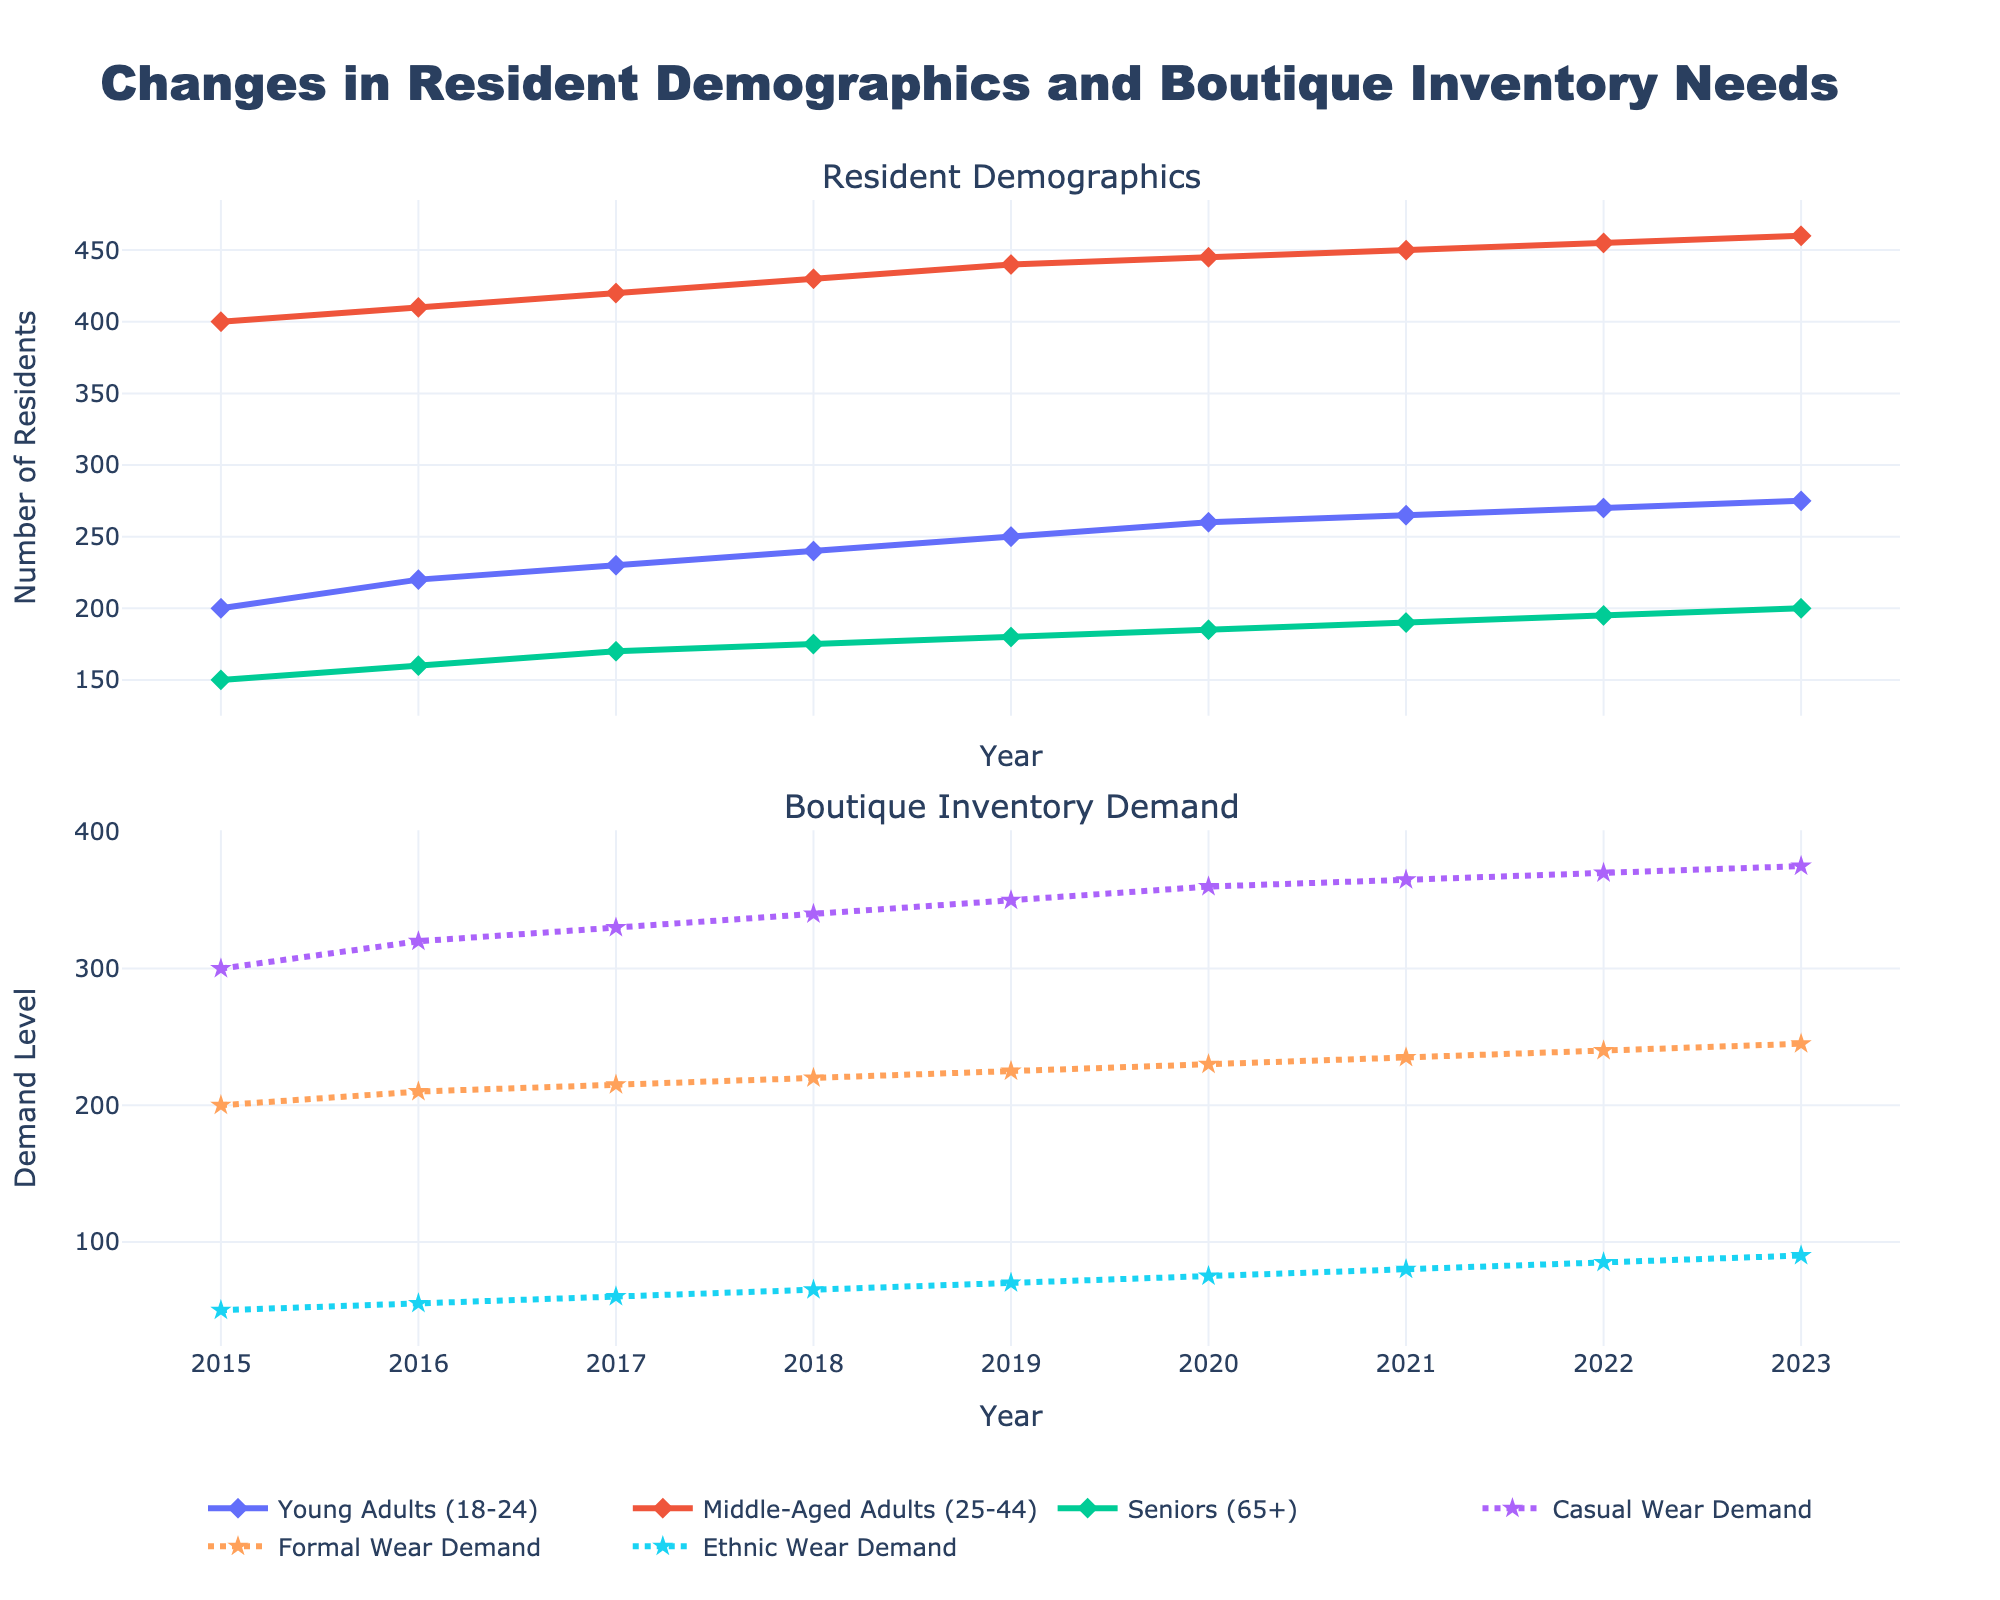What is the title of the figure? The title of the figure is typically found at the top of the plot and is used to summarize the main topic or focus.
Answer: Changes in Resident Demographics and Boutique Inventory Needs What are the two subplots showing in the figure? By examining the subplot titles, we can see that the first subplot shows "Resident Demographics" and the second subplot shows "Boutique Inventory Demand".
Answer: Resident Demographics; Boutique Inventory Demand How many data points are displayed for each series in the Resident Demographics subplot? Each series in the demographics subplot corresponds to the years from 2015 to 2023, which gives 9 data points.
Answer: 9 Between 2015 and 2023, does the demand for Casual Wear increase or decrease? Looking at the trend line for Casual Wear Demand in the second subplot, the demand for Casual Wear steadily increases from 2015 to 2023.
Answer: Increase In which year does Senior (65+) residents surpass 180 individuals? Trace the data points for Seniors in the Resident Demographics subplot and see that the number surpasses 180 in the year 2019.
Answer: 2019 Which resident age group has the largest population in 2023? By comparing the endpoints of the three demographic lines in 2023, we can see that Middle-Aged Adults (25-44) have the largest population.
Answer: Middle-Aged Adults (25-44) What is the maximum demand level for Formal Wear observed in the figure? By identifying the highest point on the Formal Wear Demand line in the second subplot, we find that the maximum demand level is 245.
Answer: 245 Calculate the average demand for Ethnic Wear from 2015 to 2023. Sum the Ethnic Wear Demand values from 2015 to 2023 and divide by 9. (50 + 55 + 60 + 65 + 70 + 75 + 80 + 85 + 90 = 630, so the average is 630/9).
Answer: 70 Which category shows a higher annual increase rate: Casual Wear Demand or Formal Wear Demand? By comparing the increments per year in the second subplot, Casual Wear Demand increases from 300 to 375 (75 units in 9 years) while Formal Wear Demand increases from 200 to 245 (45 units in 9 years). Casual Wear has a higher increase rate (75/9 > 45/9).
Answer: Casual Wear Demand Do you see any trends that align between demographic changes and changes in boutique inventory demand? Comparing the trends in the two subplots, both the resident population and the demand for different types of wear show a consistent increasing trend over the years, indicating a correlation between the growing population and rising demand.
Answer: Increasing trend correlation 